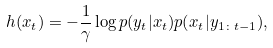Convert formula to latex. <formula><loc_0><loc_0><loc_500><loc_500>h ( x _ { t } ) = - \frac { 1 } { \gamma } \log { p ( y _ { t } | x _ { t } ) p ( x _ { t } | y _ { 1 \colon t - 1 } ) } ,</formula> 